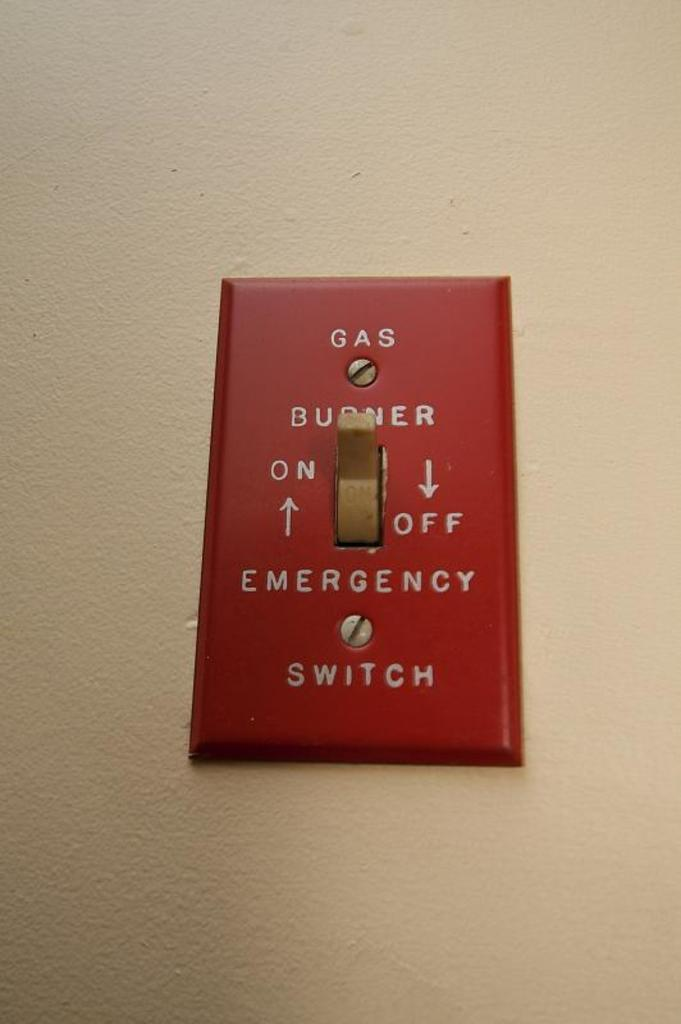<image>
Create a compact narrative representing the image presented. A red light switch says Gas Burner and is on a white wall. 